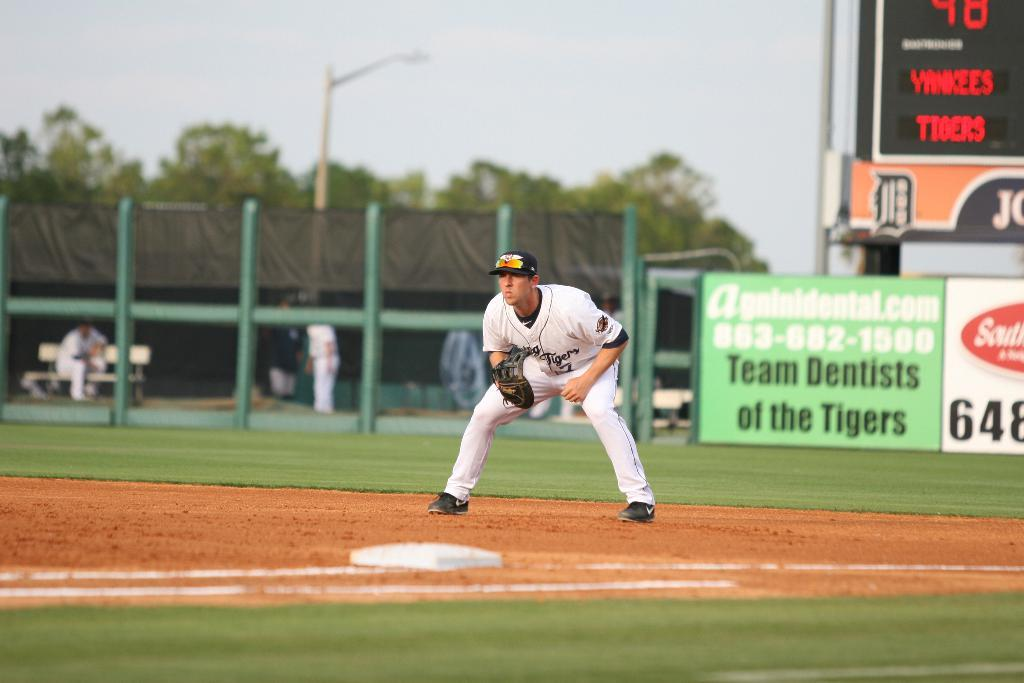<image>
Create a compact narrative representing the image presented. baseball player near a base and green sign on fence behind him that has team dentists of the tigers 